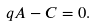Convert formula to latex. <formula><loc_0><loc_0><loc_500><loc_500>q A - C = 0 .</formula> 